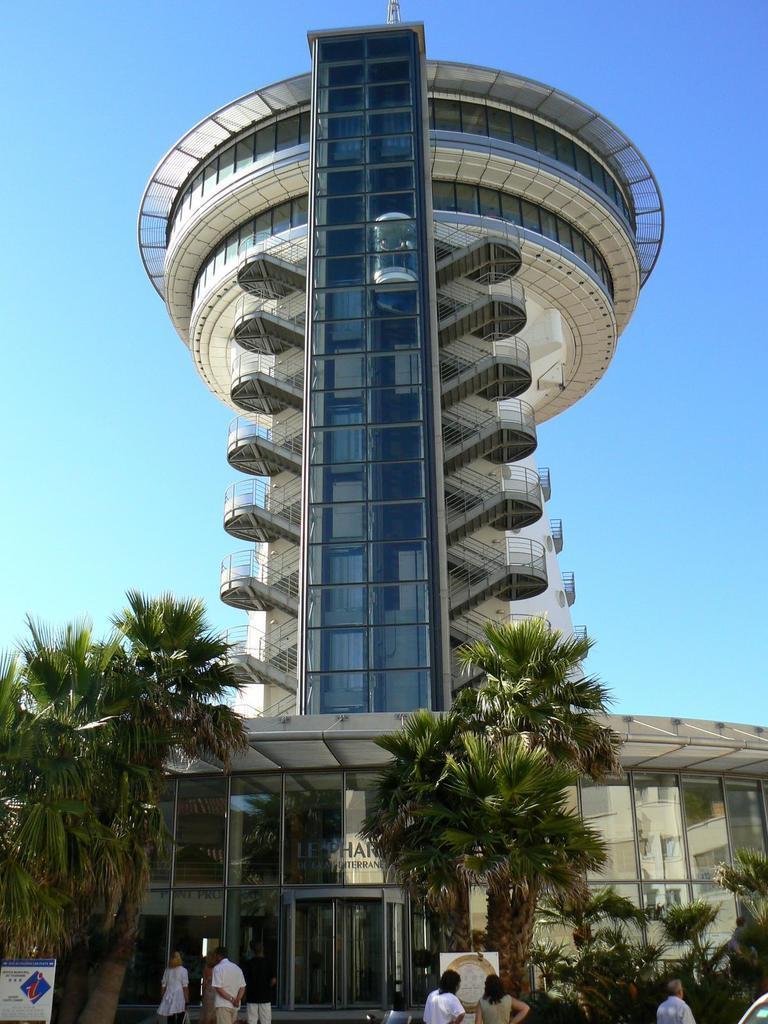Could you give a brief overview of what you see in this image? In this image we can see a few people, there is a building, windows, there are plants, trees, there are boards with text on them, also we can see the sky. 